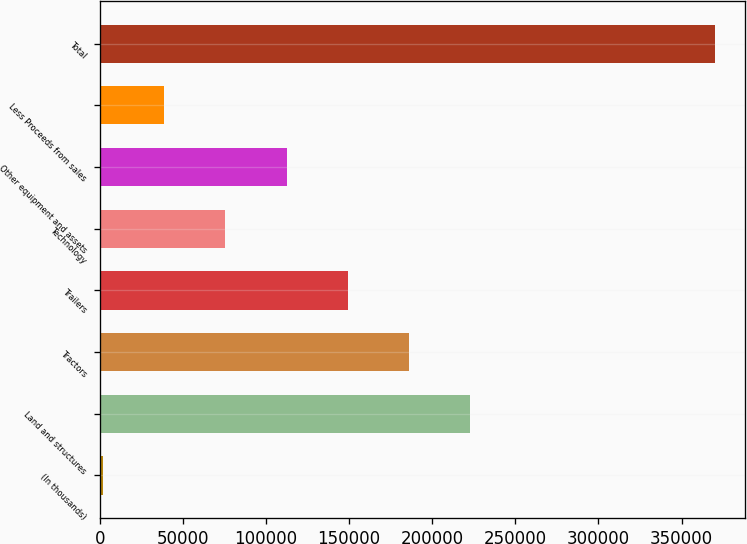Convert chart. <chart><loc_0><loc_0><loc_500><loc_500><bar_chart><fcel>(In thousands)<fcel>Land and structures<fcel>Tractors<fcel>Trailers<fcel>Technology<fcel>Other equipment and assets<fcel>Less Proceeds from sales<fcel>Total<nl><fcel>2017<fcel>222738<fcel>185951<fcel>149164<fcel>75590.6<fcel>112377<fcel>38803.8<fcel>369885<nl></chart> 